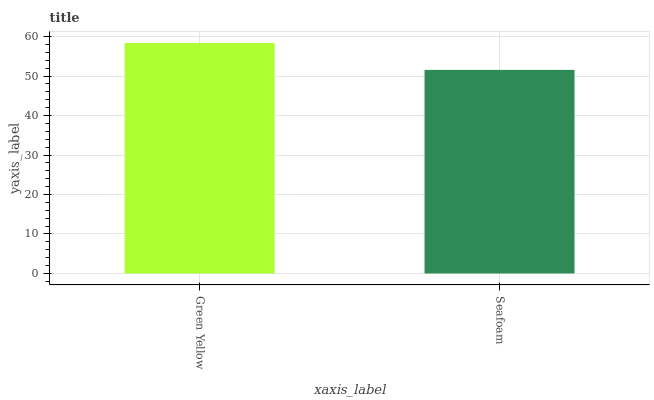Is Seafoam the minimum?
Answer yes or no. Yes. Is Green Yellow the maximum?
Answer yes or no. Yes. Is Seafoam the maximum?
Answer yes or no. No. Is Green Yellow greater than Seafoam?
Answer yes or no. Yes. Is Seafoam less than Green Yellow?
Answer yes or no. Yes. Is Seafoam greater than Green Yellow?
Answer yes or no. No. Is Green Yellow less than Seafoam?
Answer yes or no. No. Is Green Yellow the high median?
Answer yes or no. Yes. Is Seafoam the low median?
Answer yes or no. Yes. Is Seafoam the high median?
Answer yes or no. No. Is Green Yellow the low median?
Answer yes or no. No. 